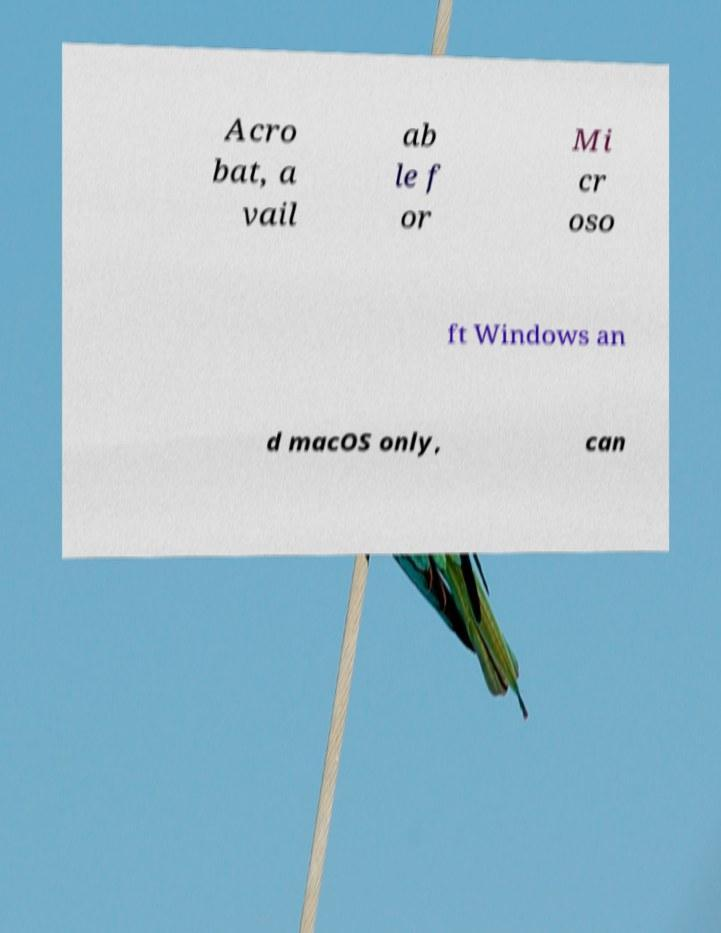Can you read and provide the text displayed in the image?This photo seems to have some interesting text. Can you extract and type it out for me? Acro bat, a vail ab le f or Mi cr oso ft Windows an d macOS only, can 